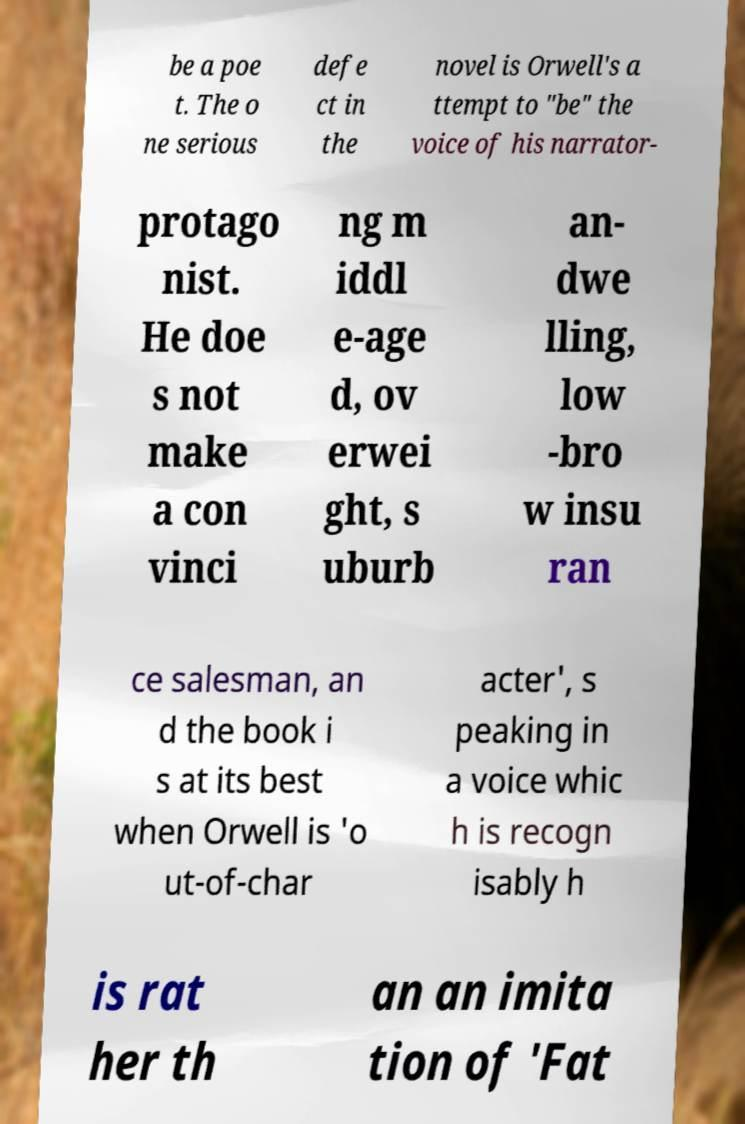Please identify and transcribe the text found in this image. be a poe t. The o ne serious defe ct in the novel is Orwell's a ttempt to "be" the voice of his narrator- protago nist. He doe s not make a con vinci ng m iddl e-age d, ov erwei ght, s uburb an- dwe lling, low -bro w insu ran ce salesman, an d the book i s at its best when Orwell is 'o ut-of-char acter', s peaking in a voice whic h is recogn isably h is rat her th an an imita tion of 'Fat 